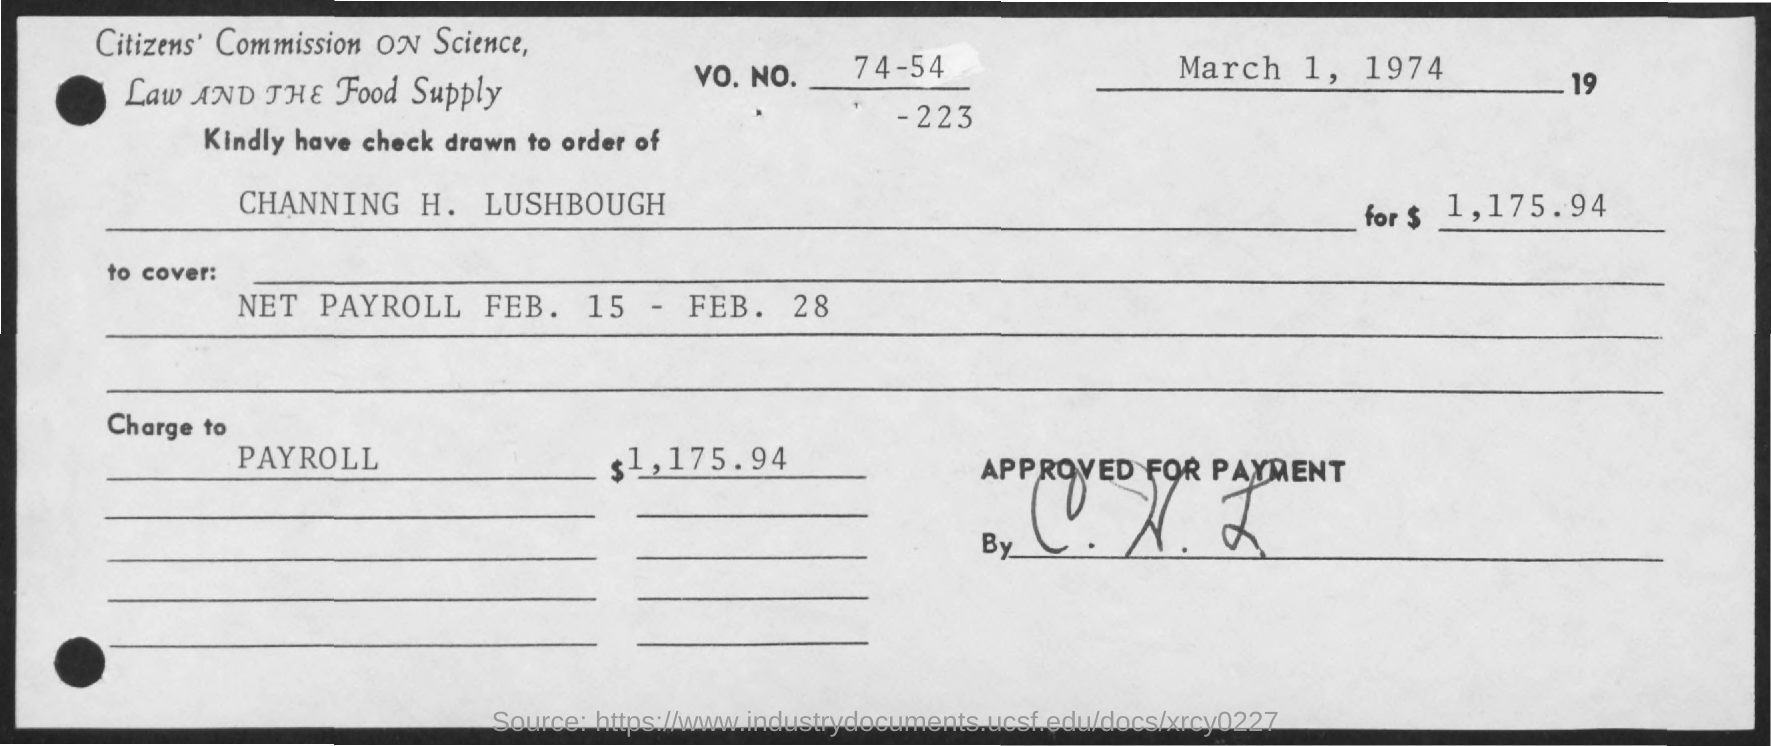Identify some key points in this picture. The check is drawn to the order of Channing H. Lushbough. The date of March 1, 1974, was on the previous day. The amount is $1,175.94. The charge to payroll for the current period is $1,175.94. What is the VO. NO.? It is 74-54-223... 